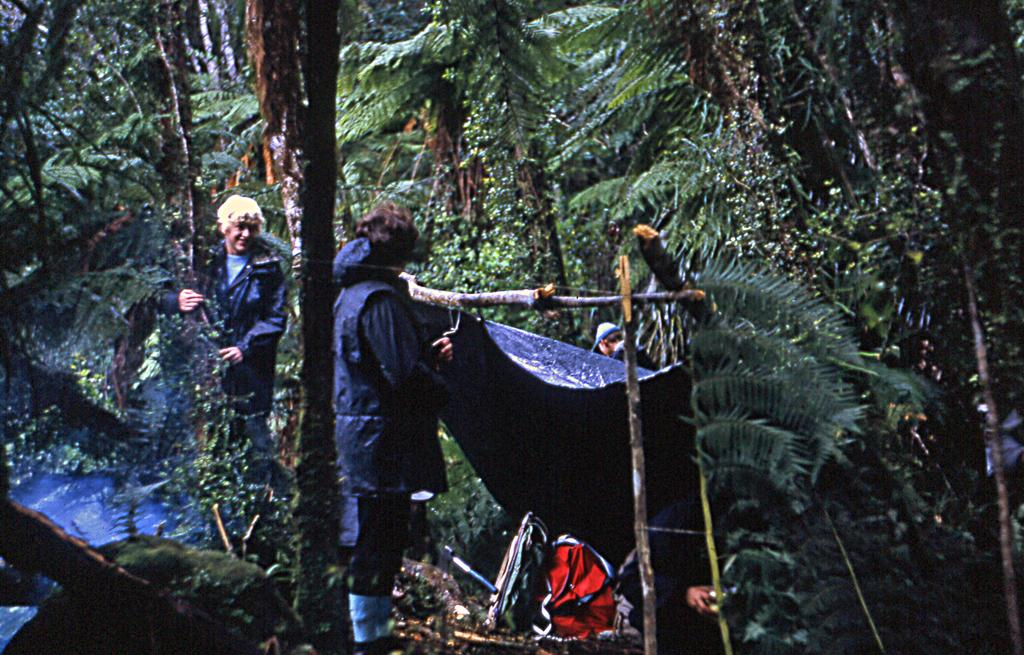How many people are in the image? There are people in the image, but the exact number is not specified. What are the people doing in the image? The people are standing around in the image. What type of natural environment is visible in the image? There are trees in the image, indicating a natural setting. What structure has been made using wooden sticks? A tent has been made with wooden sticks as pillars. What objects can be seen on the surface of the tent or ground? There are objects on the surface of the tent or ground, but their specific nature is not mentioned. What game can be heard being played in the image? There is no mention of any game or sound in the image, so it cannot be determined if a game is being played or heard. 